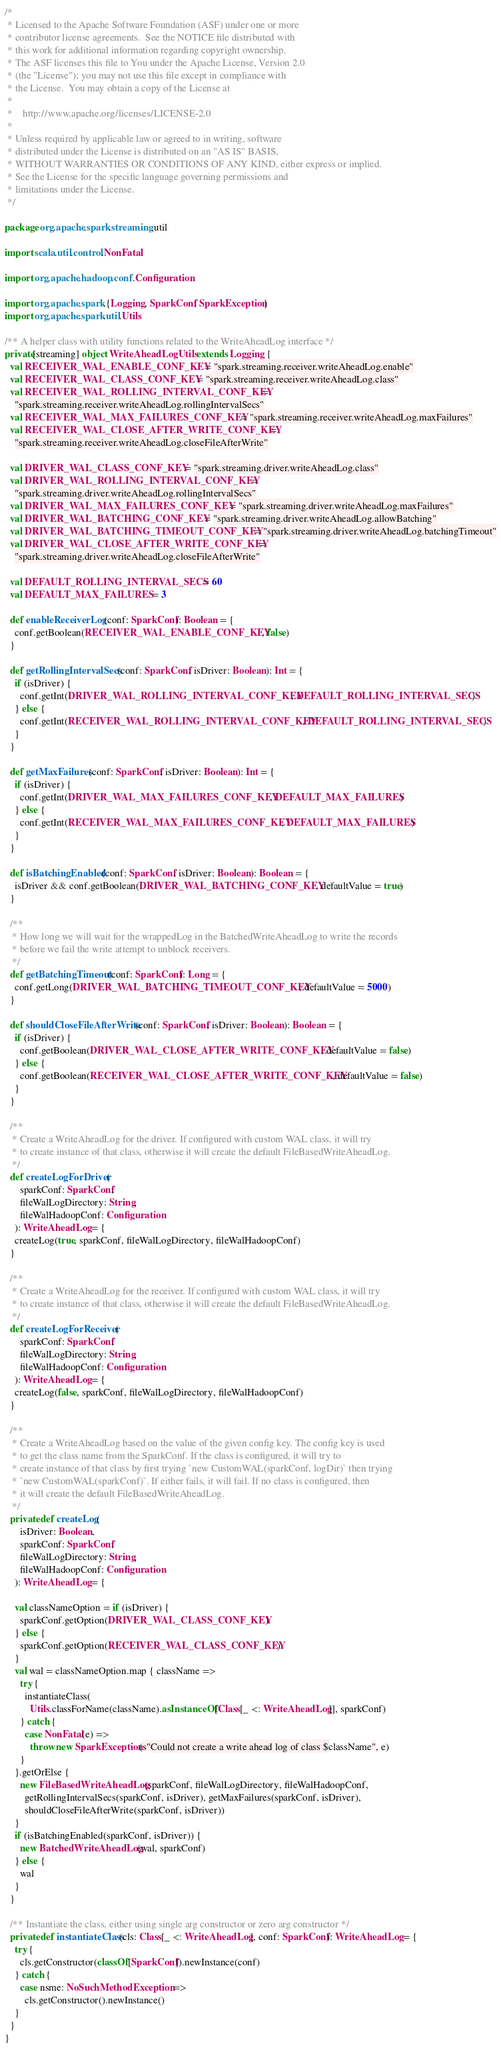<code> <loc_0><loc_0><loc_500><loc_500><_Scala_>/*
 * Licensed to the Apache Software Foundation (ASF) under one or more
 * contributor license agreements.  See the NOTICE file distributed with
 * this work for additional information regarding copyright ownership.
 * The ASF licenses this file to You under the Apache License, Version 2.0
 * (the "License"); you may not use this file except in compliance with
 * the License.  You may obtain a copy of the License at
 *
 *    http://www.apache.org/licenses/LICENSE-2.0
 *
 * Unless required by applicable law or agreed to in writing, software
 * distributed under the License is distributed on an "AS IS" BASIS,
 * WITHOUT WARRANTIES OR CONDITIONS OF ANY KIND, either express or implied.
 * See the License for the specific language governing permissions and
 * limitations under the License.
 */

package org.apache.spark.streaming.util

import scala.util.control.NonFatal

import org.apache.hadoop.conf.Configuration

import org.apache.spark.{Logging, SparkConf, SparkException}
import org.apache.spark.util.Utils

/** A helper class with utility functions related to the WriteAheadLog interface */
private[streaming] object WriteAheadLogUtils extends Logging {
  val RECEIVER_WAL_ENABLE_CONF_KEY = "spark.streaming.receiver.writeAheadLog.enable"
  val RECEIVER_WAL_CLASS_CONF_KEY = "spark.streaming.receiver.writeAheadLog.class"
  val RECEIVER_WAL_ROLLING_INTERVAL_CONF_KEY =
    "spark.streaming.receiver.writeAheadLog.rollingIntervalSecs"
  val RECEIVER_WAL_MAX_FAILURES_CONF_KEY = "spark.streaming.receiver.writeAheadLog.maxFailures"
  val RECEIVER_WAL_CLOSE_AFTER_WRITE_CONF_KEY =
    "spark.streaming.receiver.writeAheadLog.closeFileAfterWrite"

  val DRIVER_WAL_CLASS_CONF_KEY = "spark.streaming.driver.writeAheadLog.class"
  val DRIVER_WAL_ROLLING_INTERVAL_CONF_KEY =
    "spark.streaming.driver.writeAheadLog.rollingIntervalSecs"
  val DRIVER_WAL_MAX_FAILURES_CONF_KEY = "spark.streaming.driver.writeAheadLog.maxFailures"
  val DRIVER_WAL_BATCHING_CONF_KEY = "spark.streaming.driver.writeAheadLog.allowBatching"
  val DRIVER_WAL_BATCHING_TIMEOUT_CONF_KEY = "spark.streaming.driver.writeAheadLog.batchingTimeout"
  val DRIVER_WAL_CLOSE_AFTER_WRITE_CONF_KEY =
    "spark.streaming.driver.writeAheadLog.closeFileAfterWrite"

  val DEFAULT_ROLLING_INTERVAL_SECS = 60
  val DEFAULT_MAX_FAILURES = 3

  def enableReceiverLog(conf: SparkConf): Boolean = {
    conf.getBoolean(RECEIVER_WAL_ENABLE_CONF_KEY, false)
  }

  def getRollingIntervalSecs(conf: SparkConf, isDriver: Boolean): Int = {
    if (isDriver) {
      conf.getInt(DRIVER_WAL_ROLLING_INTERVAL_CONF_KEY, DEFAULT_ROLLING_INTERVAL_SECS)
    } else {
      conf.getInt(RECEIVER_WAL_ROLLING_INTERVAL_CONF_KEY, DEFAULT_ROLLING_INTERVAL_SECS)
    }
  }

  def getMaxFailures(conf: SparkConf, isDriver: Boolean): Int = {
    if (isDriver) {
      conf.getInt(DRIVER_WAL_MAX_FAILURES_CONF_KEY, DEFAULT_MAX_FAILURES)
    } else {
      conf.getInt(RECEIVER_WAL_MAX_FAILURES_CONF_KEY, DEFAULT_MAX_FAILURES)
    }
  }

  def isBatchingEnabled(conf: SparkConf, isDriver: Boolean): Boolean = {
    isDriver && conf.getBoolean(DRIVER_WAL_BATCHING_CONF_KEY, defaultValue = true)
  }

  /**
   * How long we will wait for the wrappedLog in the BatchedWriteAheadLog to write the records
   * before we fail the write attempt to unblock receivers.
   */
  def getBatchingTimeout(conf: SparkConf): Long = {
    conf.getLong(DRIVER_WAL_BATCHING_TIMEOUT_CONF_KEY, defaultValue = 5000)
  }

  def shouldCloseFileAfterWrite(conf: SparkConf, isDriver: Boolean): Boolean = {
    if (isDriver) {
      conf.getBoolean(DRIVER_WAL_CLOSE_AFTER_WRITE_CONF_KEY, defaultValue = false)
    } else {
      conf.getBoolean(RECEIVER_WAL_CLOSE_AFTER_WRITE_CONF_KEY, defaultValue = false)
    }
  }

  /**
   * Create a WriteAheadLog for the driver. If configured with custom WAL class, it will try
   * to create instance of that class, otherwise it will create the default FileBasedWriteAheadLog.
   */
  def createLogForDriver(
      sparkConf: SparkConf,
      fileWalLogDirectory: String,
      fileWalHadoopConf: Configuration
    ): WriteAheadLog = {
    createLog(true, sparkConf, fileWalLogDirectory, fileWalHadoopConf)
  }

  /**
   * Create a WriteAheadLog for the receiver. If configured with custom WAL class, it will try
   * to create instance of that class, otherwise it will create the default FileBasedWriteAheadLog.
   */
  def createLogForReceiver(
      sparkConf: SparkConf,
      fileWalLogDirectory: String,
      fileWalHadoopConf: Configuration
    ): WriteAheadLog = {
    createLog(false, sparkConf, fileWalLogDirectory, fileWalHadoopConf)
  }

  /**
   * Create a WriteAheadLog based on the value of the given config key. The config key is used
   * to get the class name from the SparkConf. If the class is configured, it will try to
   * create instance of that class by first trying `new CustomWAL(sparkConf, logDir)` then trying
   * `new CustomWAL(sparkConf)`. If either fails, it will fail. If no class is configured, then
   * it will create the default FileBasedWriteAheadLog.
   */
  private def createLog(
      isDriver: Boolean,
      sparkConf: SparkConf,
      fileWalLogDirectory: String,
      fileWalHadoopConf: Configuration
    ): WriteAheadLog = {

    val classNameOption = if (isDriver) {
      sparkConf.getOption(DRIVER_WAL_CLASS_CONF_KEY)
    } else {
      sparkConf.getOption(RECEIVER_WAL_CLASS_CONF_KEY)
    }
    val wal = classNameOption.map { className =>
      try {
        instantiateClass(
          Utils.classForName(className).asInstanceOf[Class[_ <: WriteAheadLog]], sparkConf)
      } catch {
        case NonFatal(e) =>
          throw new SparkException(s"Could not create a write ahead log of class $className", e)
      }
    }.getOrElse {
      new FileBasedWriteAheadLog(sparkConf, fileWalLogDirectory, fileWalHadoopConf,
        getRollingIntervalSecs(sparkConf, isDriver), getMaxFailures(sparkConf, isDriver),
        shouldCloseFileAfterWrite(sparkConf, isDriver))
    }
    if (isBatchingEnabled(sparkConf, isDriver)) {
      new BatchedWriteAheadLog(wal, sparkConf)
    } else {
      wal
    }
  }

  /** Instantiate the class, either using single arg constructor or zero arg constructor */
  private def instantiateClass(cls: Class[_ <: WriteAheadLog], conf: SparkConf): WriteAheadLog = {
    try {
      cls.getConstructor(classOf[SparkConf]).newInstance(conf)
    } catch {
      case nsme: NoSuchMethodException =>
        cls.getConstructor().newInstance()
    }
  }
}
</code> 